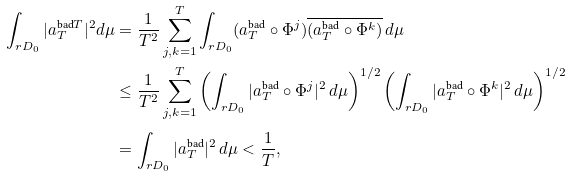<formula> <loc_0><loc_0><loc_500><loc_500>\int _ { r D _ { 0 } } | a _ { T } ^ { \text {bad} T } | ^ { 2 } d \mu & = \frac { 1 } { T ^ { 2 } } \sum _ { j , k = 1 } ^ { T } \int _ { r D _ { 0 } } ( a _ { T } ^ { \text {bad} } \circ \Phi ^ { j } ) \overline { ( a _ { T } ^ { \text {bad} } \circ \Phi ^ { k } ) } \, d \mu \\ & \leq \frac { 1 } { T ^ { 2 } } \sum _ { j , k = 1 } ^ { T } \left ( \int _ { r D _ { 0 } } | a _ { T } ^ { \text {bad} } \circ \Phi ^ { j } | ^ { 2 } \, d \mu \right ) ^ { 1 / 2 } \left ( \int _ { r D _ { 0 } } | a _ { T } ^ { \text {bad} } \circ \Phi ^ { k } | ^ { 2 } \, d \mu \right ) ^ { 1 / 2 } \\ & = \int _ { r D _ { 0 } } | a _ { T } ^ { \text {bad} } | ^ { 2 } \, d \mu < \frac { 1 } { T } ,</formula> 